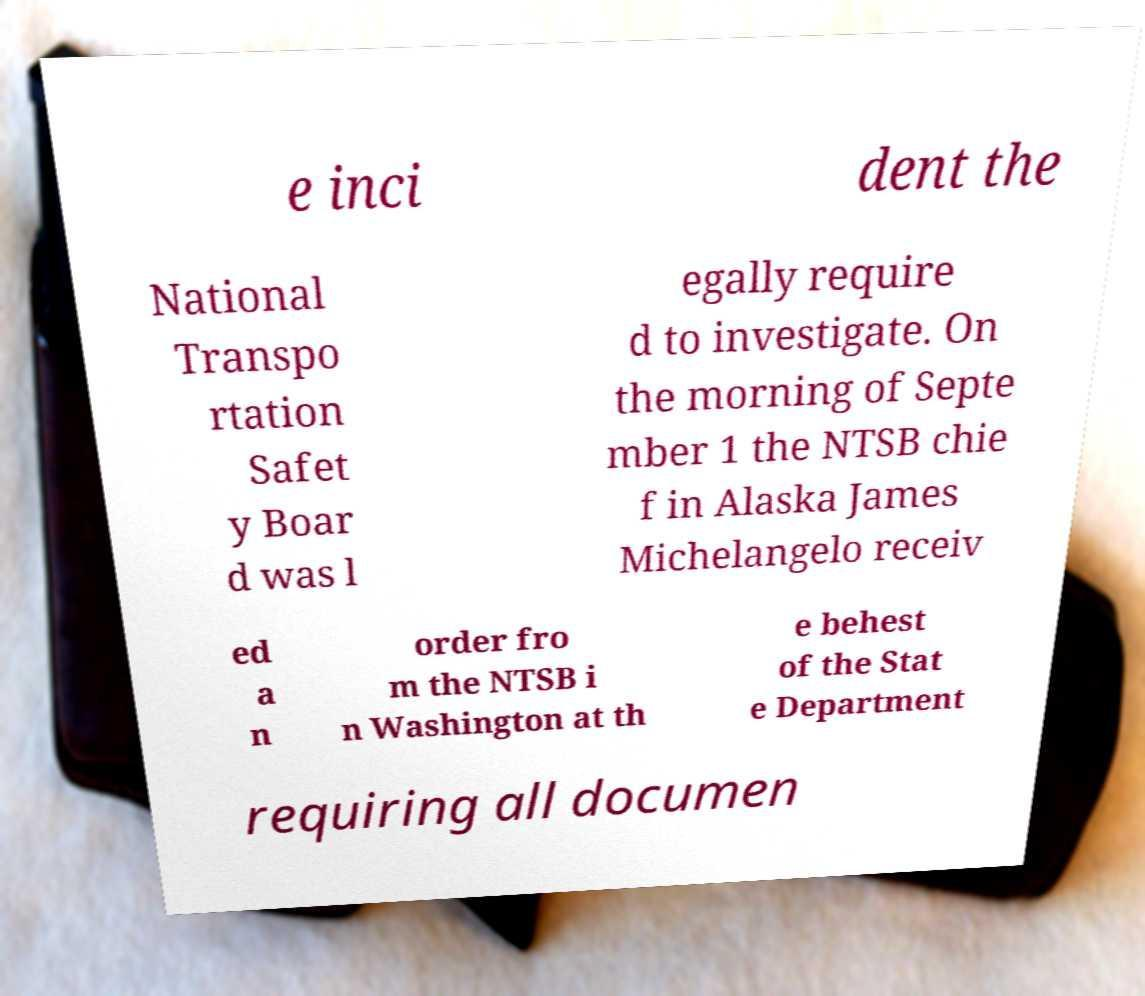What messages or text are displayed in this image? I need them in a readable, typed format. e inci dent the National Transpo rtation Safet y Boar d was l egally require d to investigate. On the morning of Septe mber 1 the NTSB chie f in Alaska James Michelangelo receiv ed a n order fro m the NTSB i n Washington at th e behest of the Stat e Department requiring all documen 